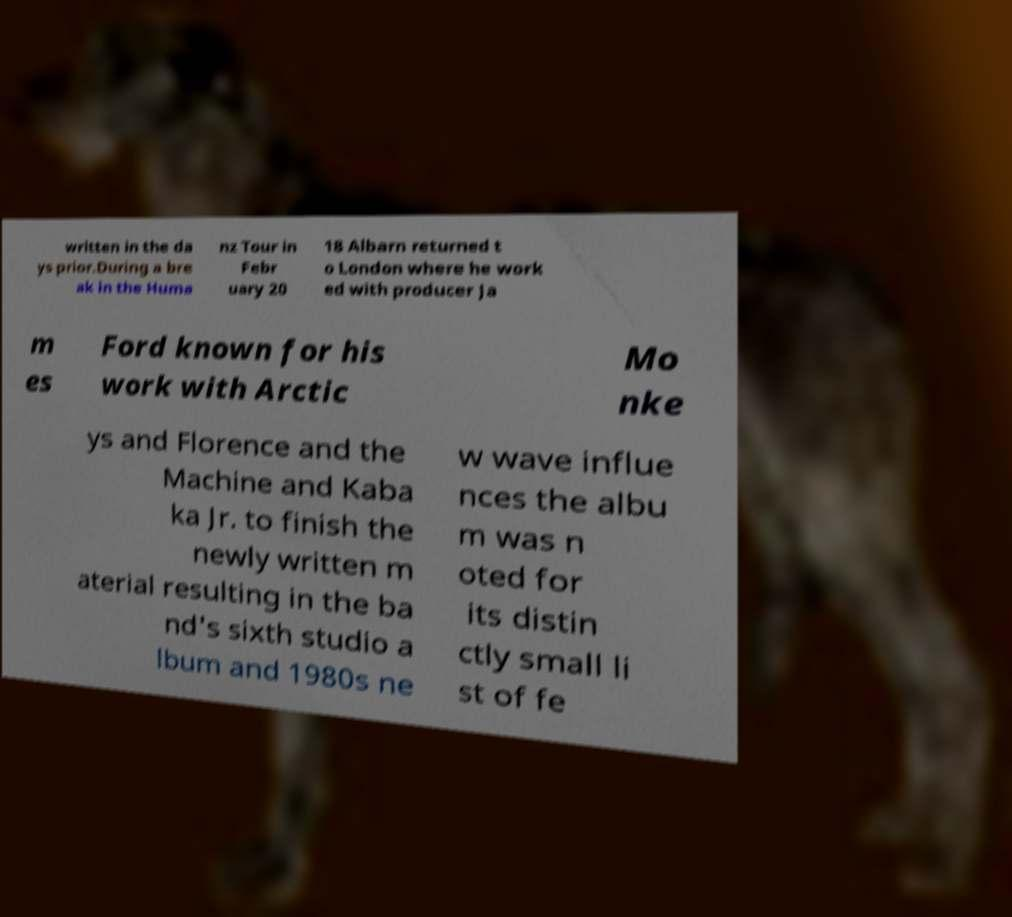Could you extract and type out the text from this image? written in the da ys prior.During a bre ak in the Huma nz Tour in Febr uary 20 18 Albarn returned t o London where he work ed with producer Ja m es Ford known for his work with Arctic Mo nke ys and Florence and the Machine and Kaba ka Jr. to finish the newly written m aterial resulting in the ba nd's sixth studio a lbum and 1980s ne w wave influe nces the albu m was n oted for its distin ctly small li st of fe 